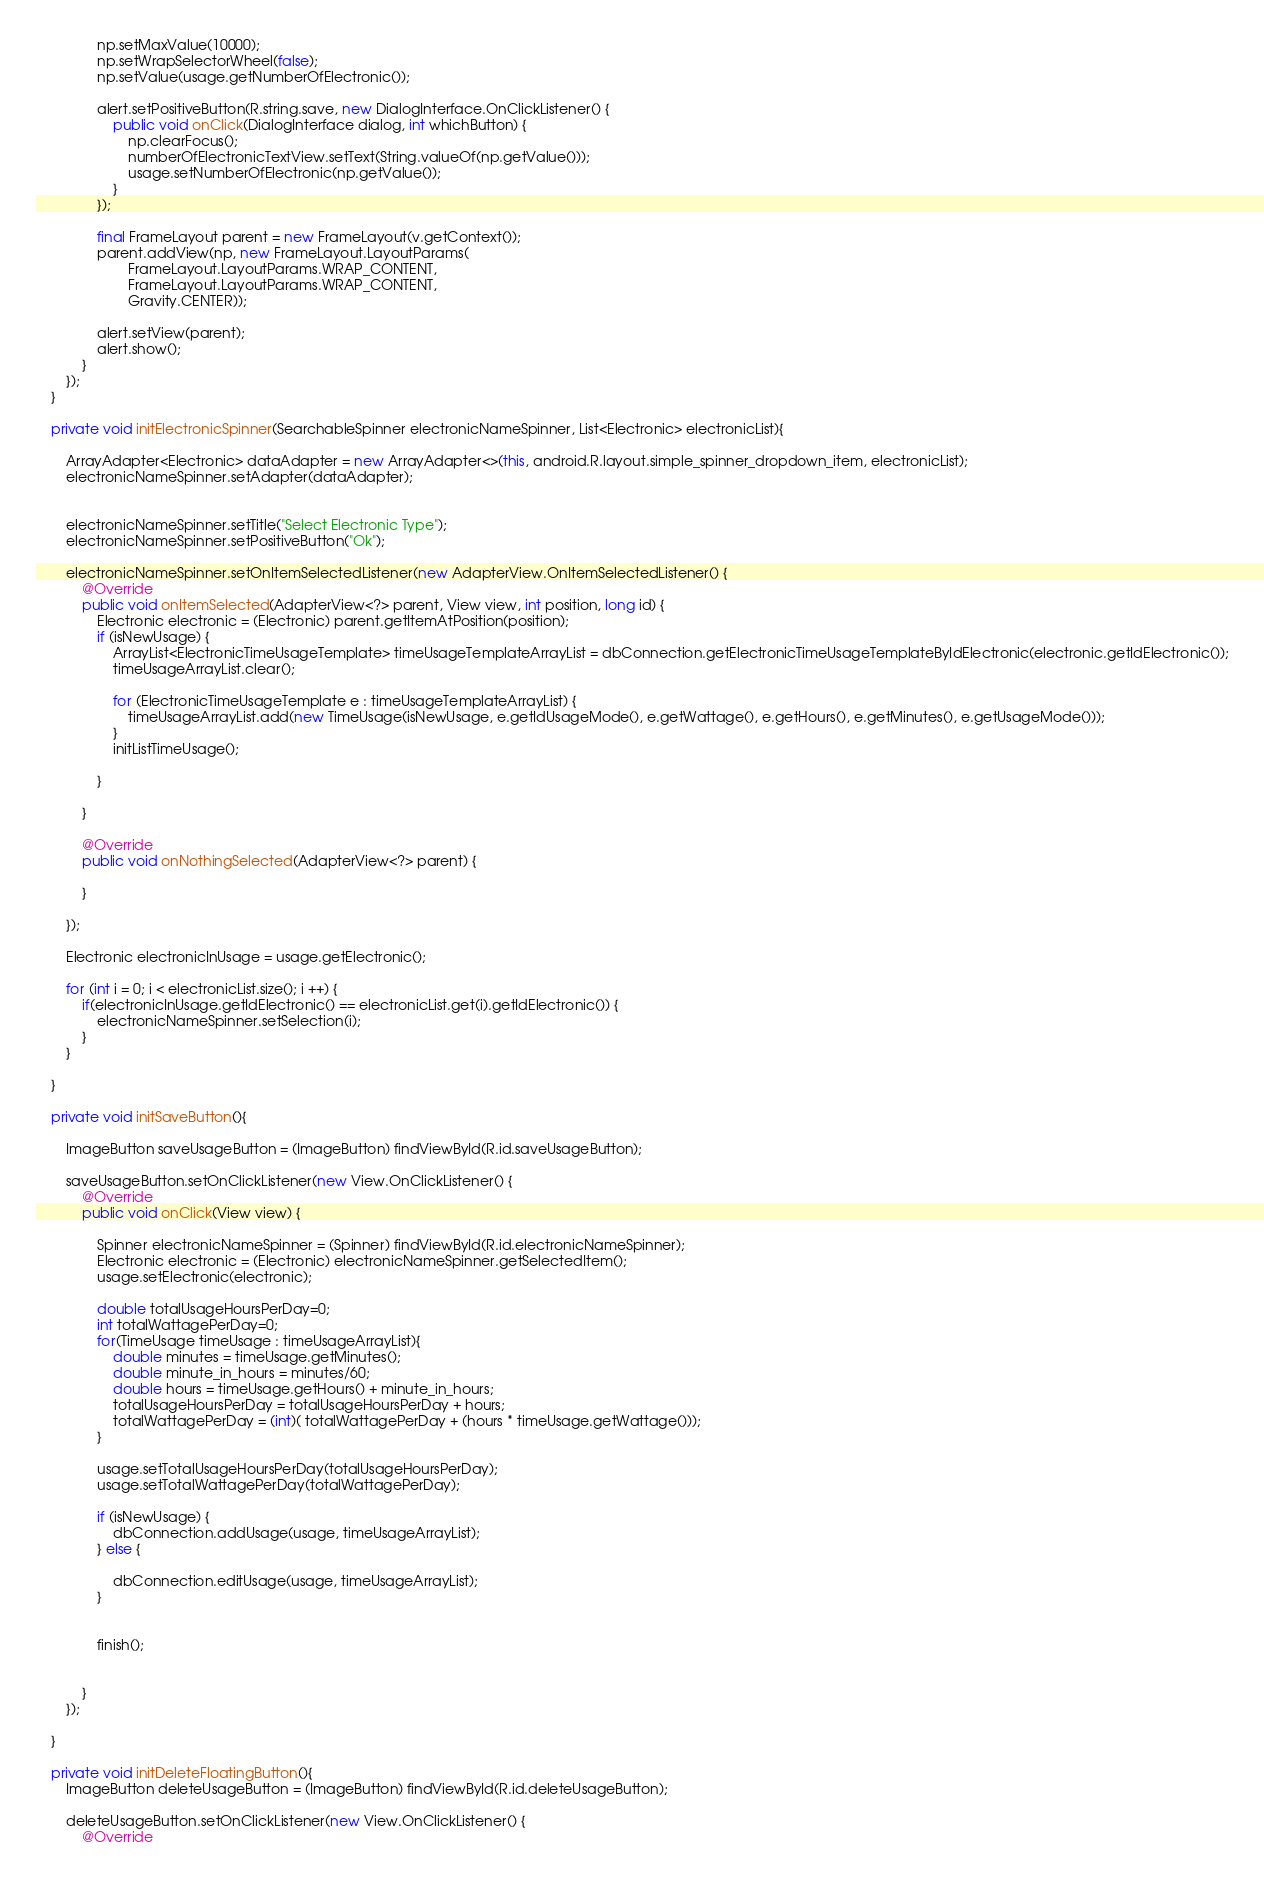<code> <loc_0><loc_0><loc_500><loc_500><_Java_>                np.setMaxValue(10000);
                np.setWrapSelectorWheel(false);
                np.setValue(usage.getNumberOfElectronic());

                alert.setPositiveButton(R.string.save, new DialogInterface.OnClickListener() {
                    public void onClick(DialogInterface dialog, int whichButton) {
                        np.clearFocus();
                        numberOfElectronicTextView.setText(String.valueOf(np.getValue()));
                        usage.setNumberOfElectronic(np.getValue());
                    }
                });

                final FrameLayout parent = new FrameLayout(v.getContext());
                parent.addView(np, new FrameLayout.LayoutParams(
                        FrameLayout.LayoutParams.WRAP_CONTENT,
                        FrameLayout.LayoutParams.WRAP_CONTENT,
                        Gravity.CENTER));

                alert.setView(parent);
                alert.show();
            }
        });
    }

    private void initElectronicSpinner(SearchableSpinner electronicNameSpinner, List<Electronic> electronicList){

        ArrayAdapter<Electronic> dataAdapter = new ArrayAdapter<>(this, android.R.layout.simple_spinner_dropdown_item, electronicList);
        electronicNameSpinner.setAdapter(dataAdapter);


        electronicNameSpinner.setTitle("Select Electronic Type");
        electronicNameSpinner.setPositiveButton("Ok");

        electronicNameSpinner.setOnItemSelectedListener(new AdapterView.OnItemSelectedListener() {
            @Override
            public void onItemSelected(AdapterView<?> parent, View view, int position, long id) {
                Electronic electronic = (Electronic) parent.getItemAtPosition(position);
                if (isNewUsage) {
                    ArrayList<ElectronicTimeUsageTemplate> timeUsageTemplateArrayList = dbConnection.getElectronicTimeUsageTemplateByIdElectronic(electronic.getIdElectronic());
                    timeUsageArrayList.clear();

                    for (ElectronicTimeUsageTemplate e : timeUsageTemplateArrayList) {
                        timeUsageArrayList.add(new TimeUsage(isNewUsage, e.getIdUsageMode(), e.getWattage(), e.getHours(), e.getMinutes(), e.getUsageMode()));
                    }
                    initListTimeUsage();

                }

            }

            @Override
            public void onNothingSelected(AdapterView<?> parent) {

            }

        });

        Electronic electronicInUsage = usage.getElectronic();

        for (int i = 0; i < electronicList.size(); i ++) {
            if(electronicInUsage.getIdElectronic() == electronicList.get(i).getIdElectronic()) {
                electronicNameSpinner.setSelection(i);
            }
        }

    }

    private void initSaveButton(){

        ImageButton saveUsageButton = (ImageButton) findViewById(R.id.saveUsageButton);

        saveUsageButton.setOnClickListener(new View.OnClickListener() {
            @Override
            public void onClick(View view) {

                Spinner electronicNameSpinner = (Spinner) findViewById(R.id.electronicNameSpinner);
                Electronic electronic = (Electronic) electronicNameSpinner.getSelectedItem();
                usage.setElectronic(electronic);

                double totalUsageHoursPerDay=0;
                int totalWattagePerDay=0;
                for(TimeUsage timeUsage : timeUsageArrayList){
                    double minutes = timeUsage.getMinutes();
                    double minute_in_hours = minutes/60;
                    double hours = timeUsage.getHours() + minute_in_hours;
                    totalUsageHoursPerDay = totalUsageHoursPerDay + hours;
                    totalWattagePerDay = (int)( totalWattagePerDay + (hours * timeUsage.getWattage()));
                }

                usage.setTotalUsageHoursPerDay(totalUsageHoursPerDay);
                usage.setTotalWattagePerDay(totalWattagePerDay);

                if (isNewUsage) {
                    dbConnection.addUsage(usage, timeUsageArrayList);
                } else {

                    dbConnection.editUsage(usage, timeUsageArrayList);
                }


                finish();


            }
        });

    }

    private void initDeleteFloatingButton(){
        ImageButton deleteUsageButton = (ImageButton) findViewById(R.id.deleteUsageButton);

        deleteUsageButton.setOnClickListener(new View.OnClickListener() {
            @Override</code> 